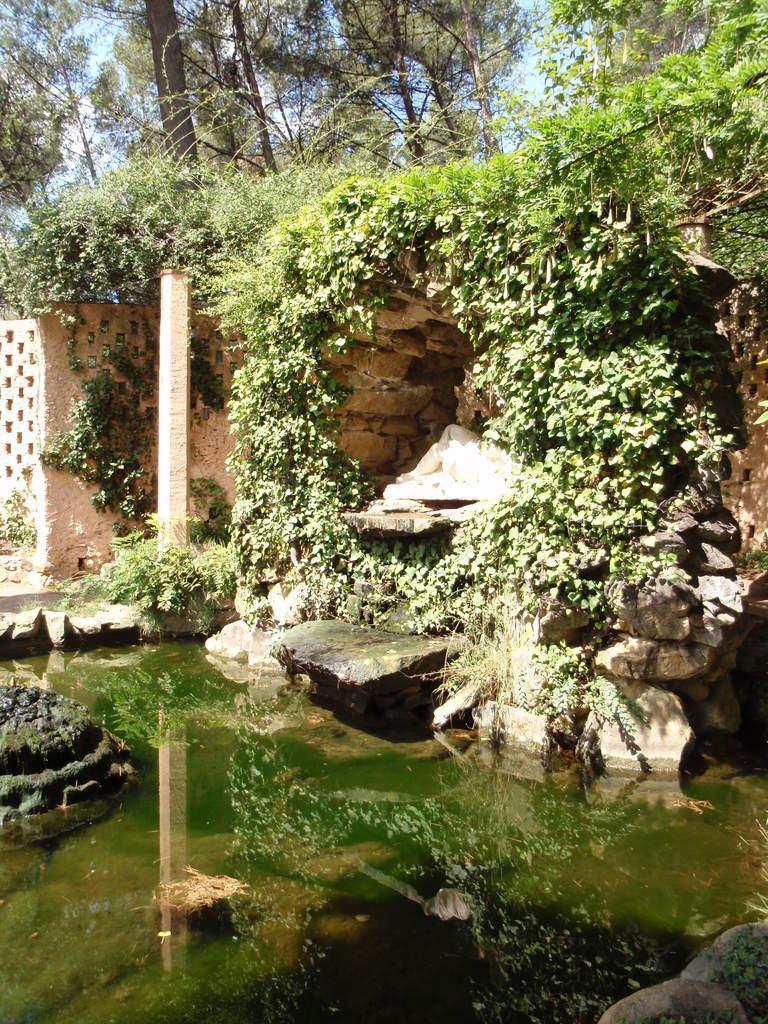Please provide a concise description of this image. In this image we can see a water, here are the rocks, here is the wall, here are the trees, at above here is the sky. 